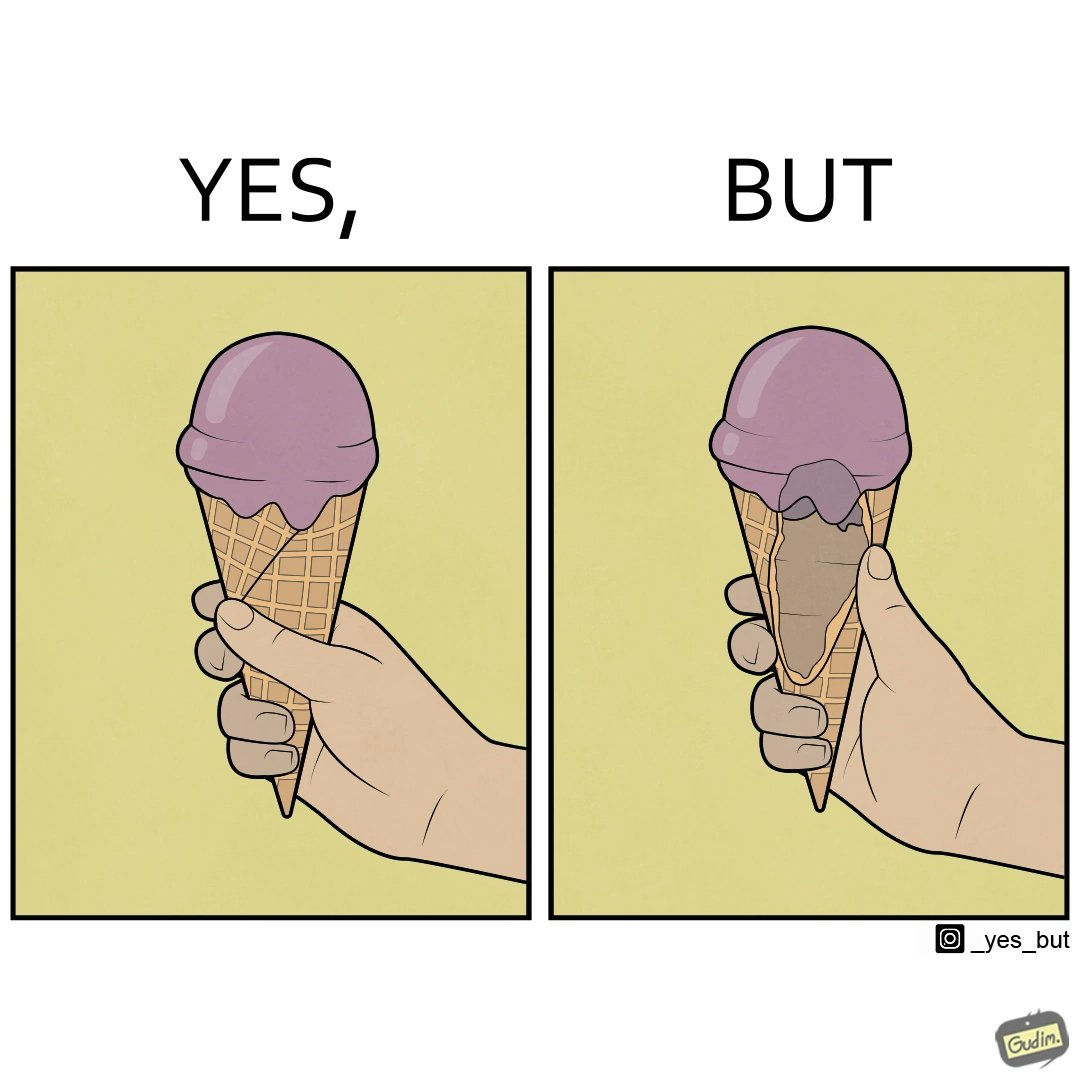What makes this image funny or satirical? The image is ironic, because in one image the softy cone is shown filled with softy but in second image it is visible that only the top of the cone is filled and at the inside the cone is vacant 